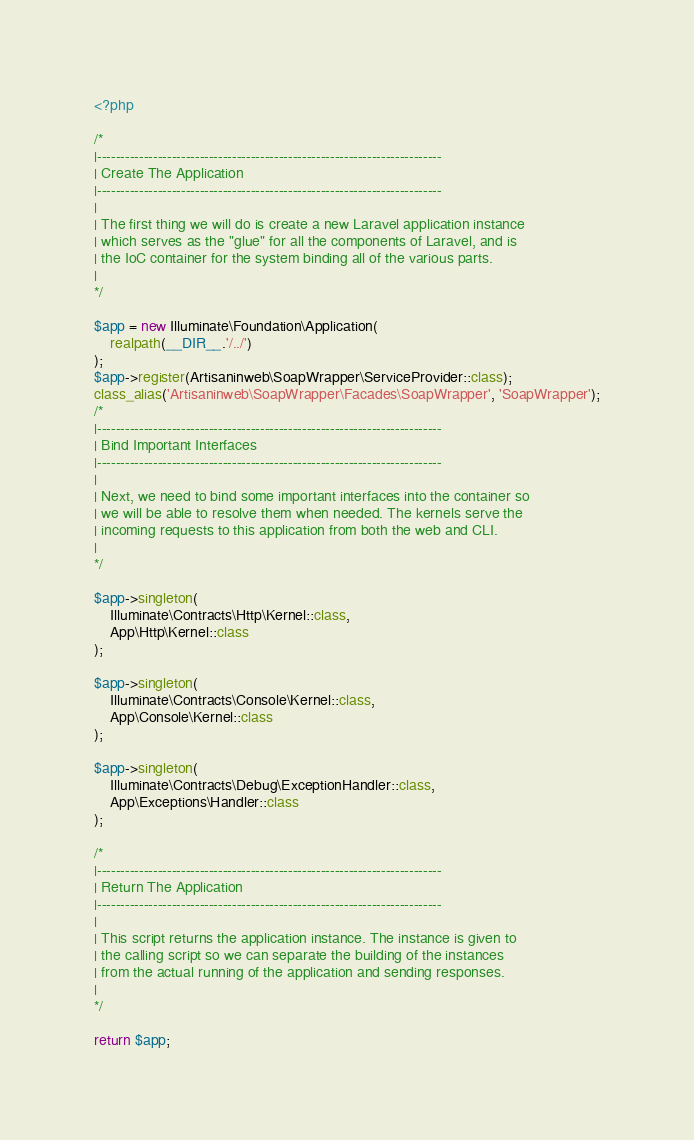Convert code to text. <code><loc_0><loc_0><loc_500><loc_500><_PHP_><?php

/*
|--------------------------------------------------------------------------
| Create The Application
|--------------------------------------------------------------------------
|
| The first thing we will do is create a new Laravel application instance
| which serves as the "glue" for all the components of Laravel, and is
| the IoC container for the system binding all of the various parts.
|
*/

$app = new Illuminate\Foundation\Application(
    realpath(__DIR__.'/../')
);
$app->register(Artisaninweb\SoapWrapper\ServiceProvider::class);
class_alias('Artisaninweb\SoapWrapper\Facades\SoapWrapper', 'SoapWrapper');
/*
|--------------------------------------------------------------------------
| Bind Important Interfaces
|--------------------------------------------------------------------------
|
| Next, we need to bind some important interfaces into the container so
| we will be able to resolve them when needed. The kernels serve the
| incoming requests to this application from both the web and CLI.
|
*/

$app->singleton(
    Illuminate\Contracts\Http\Kernel::class,
    App\Http\Kernel::class
);

$app->singleton(
    Illuminate\Contracts\Console\Kernel::class,
    App\Console\Kernel::class
);

$app->singleton(
    Illuminate\Contracts\Debug\ExceptionHandler::class,
    App\Exceptions\Handler::class
);

/*
|--------------------------------------------------------------------------
| Return The Application
|--------------------------------------------------------------------------
|
| This script returns the application instance. The instance is given to
| the calling script so we can separate the building of the instances
| from the actual running of the application and sending responses.
|
*/

return $app;
</code> 